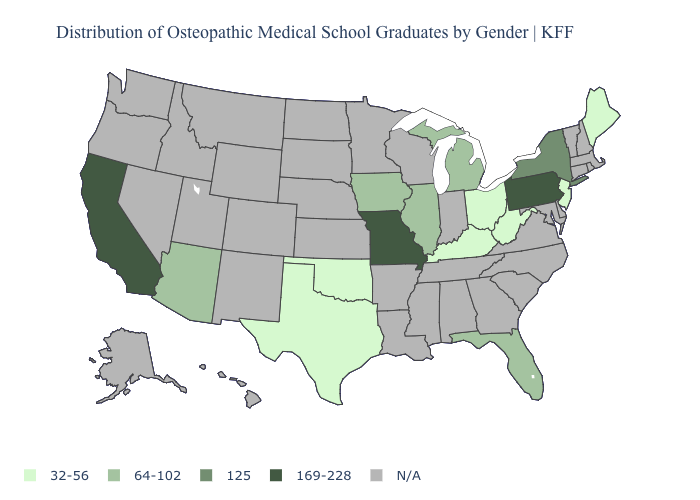What is the value of Alabama?
Give a very brief answer. N/A. Does the first symbol in the legend represent the smallest category?
Be succinct. Yes. Name the states that have a value in the range 32-56?
Be succinct. Kentucky, Maine, New Jersey, Ohio, Oklahoma, Texas, West Virginia. Does the first symbol in the legend represent the smallest category?
Keep it brief. Yes. Name the states that have a value in the range 169-228?
Write a very short answer. California, Missouri, Pennsylvania. Name the states that have a value in the range 32-56?
Short answer required. Kentucky, Maine, New Jersey, Ohio, Oklahoma, Texas, West Virginia. Which states have the lowest value in the USA?
Give a very brief answer. Kentucky, Maine, New Jersey, Ohio, Oklahoma, Texas, West Virginia. What is the value of Missouri?
Be succinct. 169-228. Among the states that border Delaware , which have the highest value?
Keep it brief. Pennsylvania. Does the first symbol in the legend represent the smallest category?
Answer briefly. Yes. What is the value of Georgia?
Short answer required. N/A. What is the value of Louisiana?
Answer briefly. N/A. What is the value of New Jersey?
Write a very short answer. 32-56. What is the lowest value in the USA?
Be succinct. 32-56. 